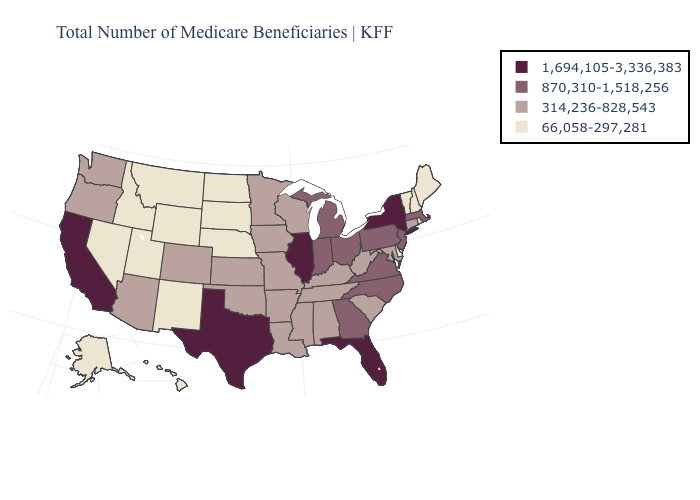What is the highest value in the West ?
Short answer required. 1,694,105-3,336,383. What is the value of Iowa?
Give a very brief answer. 314,236-828,543. Name the states that have a value in the range 1,694,105-3,336,383?
Concise answer only. California, Florida, Illinois, New York, Texas. Name the states that have a value in the range 66,058-297,281?
Quick response, please. Alaska, Delaware, Hawaii, Idaho, Maine, Montana, Nebraska, Nevada, New Hampshire, New Mexico, North Dakota, Rhode Island, South Dakota, Utah, Vermont, Wyoming. Which states hav the highest value in the South?
Keep it brief. Florida, Texas. What is the lowest value in states that border New Hampshire?
Keep it brief. 66,058-297,281. What is the value of Tennessee?
Write a very short answer. 314,236-828,543. Name the states that have a value in the range 66,058-297,281?
Be succinct. Alaska, Delaware, Hawaii, Idaho, Maine, Montana, Nebraska, Nevada, New Hampshire, New Mexico, North Dakota, Rhode Island, South Dakota, Utah, Vermont, Wyoming. Name the states that have a value in the range 66,058-297,281?
Short answer required. Alaska, Delaware, Hawaii, Idaho, Maine, Montana, Nebraska, Nevada, New Hampshire, New Mexico, North Dakota, Rhode Island, South Dakota, Utah, Vermont, Wyoming. Does Idaho have the lowest value in the West?
Keep it brief. Yes. Name the states that have a value in the range 1,694,105-3,336,383?
Concise answer only. California, Florida, Illinois, New York, Texas. Does Oregon have the lowest value in the West?
Keep it brief. No. What is the value of Arizona?
Be succinct. 314,236-828,543. Which states have the lowest value in the West?
Short answer required. Alaska, Hawaii, Idaho, Montana, Nevada, New Mexico, Utah, Wyoming. Name the states that have a value in the range 314,236-828,543?
Give a very brief answer. Alabama, Arizona, Arkansas, Colorado, Connecticut, Iowa, Kansas, Kentucky, Louisiana, Maryland, Minnesota, Mississippi, Missouri, Oklahoma, Oregon, South Carolina, Tennessee, Washington, West Virginia, Wisconsin. 